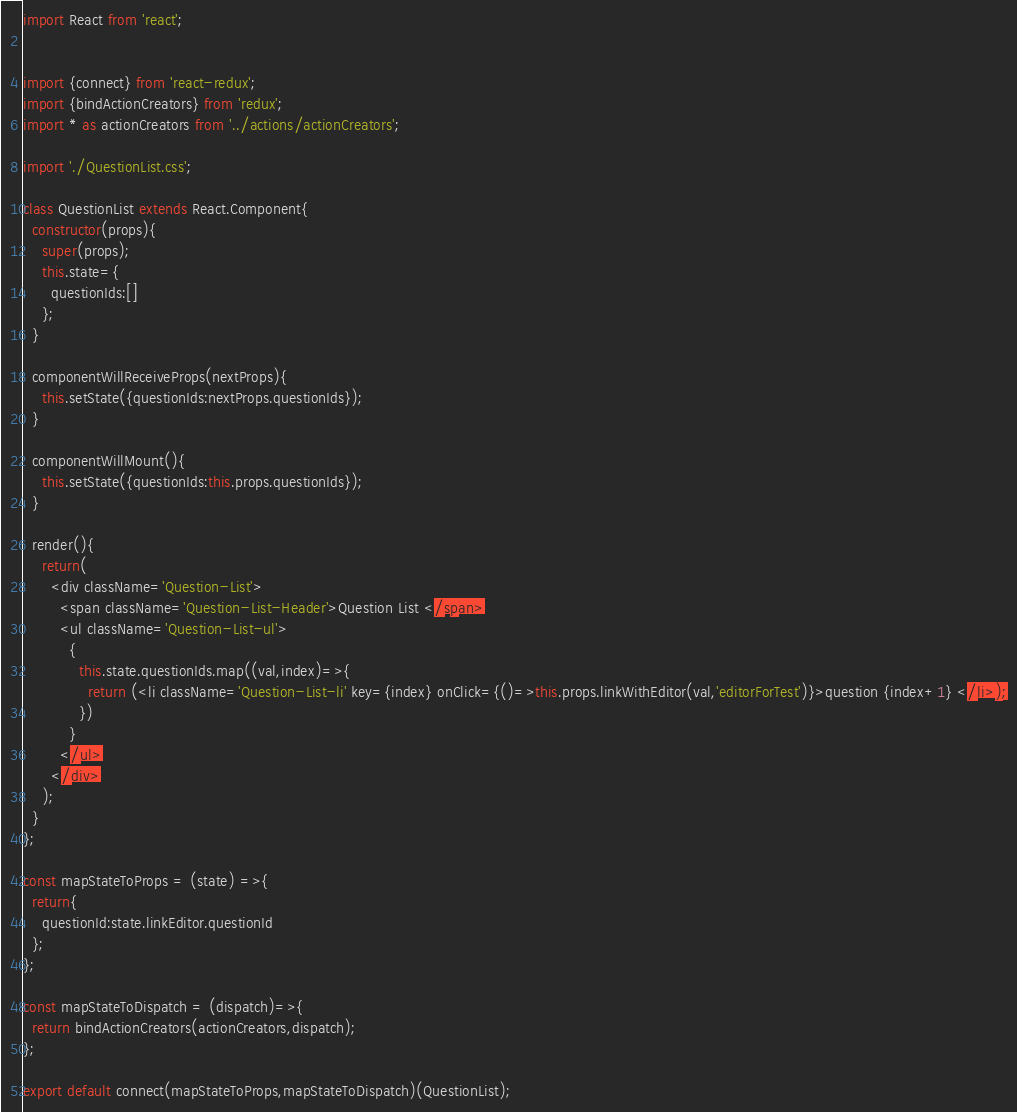<code> <loc_0><loc_0><loc_500><loc_500><_JavaScript_>import React from 'react';


import {connect} from 'react-redux';
import {bindActionCreators} from 'redux';
import * as actionCreators from '../actions/actionCreators';

import './QuestionList.css';

class QuestionList extends React.Component{
  constructor(props){
    super(props);
    this.state={
      questionIds:[]
    };
  }

  componentWillReceiveProps(nextProps){
    this.setState({questionIds:nextProps.questionIds});
  }

  componentWillMount(){
    this.setState({questionIds:this.props.questionIds});
  }

  render(){
    return(
      <div className='Question-List'>
        <span className='Question-List-Header'>Question List </span>
        <ul className='Question-List-ul'>
          {
            this.state.questionIds.map((val,index)=>{
              return (<li className='Question-List-li' key={index} onClick={()=>this.props.linkWithEditor(val,'editorForTest')}>question {index+1} </li>);
            })
          }
        </ul>
      </div>
    );
  }
};

const mapStateToProps = (state) =>{
  return{
    questionId:state.linkEditor.questionId
  };
};

const mapStateToDispatch = (dispatch)=>{
  return bindActionCreators(actionCreators,dispatch);
};

export default connect(mapStateToProps,mapStateToDispatch)(QuestionList);
</code> 